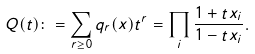<formula> <loc_0><loc_0><loc_500><loc_500>Q ( t ) \colon = \sum _ { r \geq 0 } q _ { r } ( x ) t ^ { r } = \prod _ { i } \frac { 1 + t x _ { i } } { 1 - t x _ { i } } .</formula> 